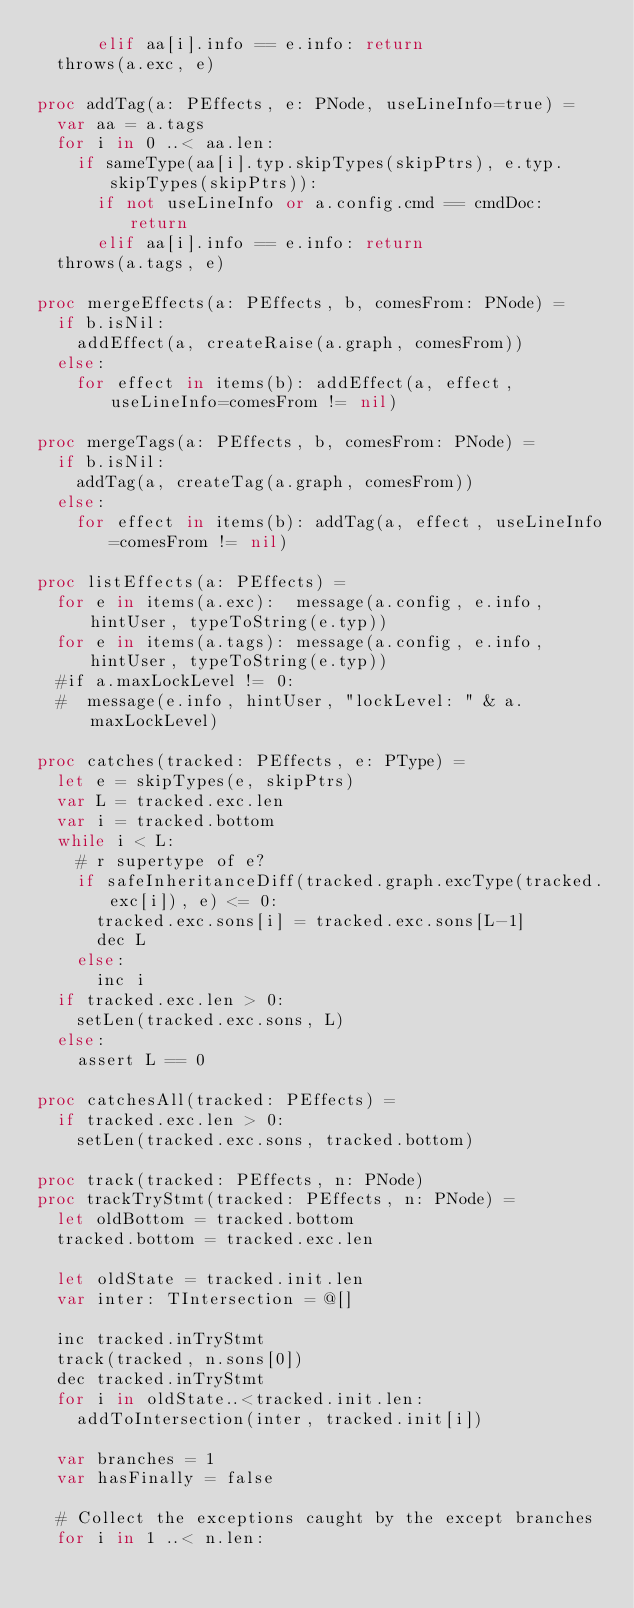<code> <loc_0><loc_0><loc_500><loc_500><_Nim_>      elif aa[i].info == e.info: return
  throws(a.exc, e)

proc addTag(a: PEffects, e: PNode, useLineInfo=true) =
  var aa = a.tags
  for i in 0 ..< aa.len:
    if sameType(aa[i].typ.skipTypes(skipPtrs), e.typ.skipTypes(skipPtrs)):
      if not useLineInfo or a.config.cmd == cmdDoc: return
      elif aa[i].info == e.info: return
  throws(a.tags, e)

proc mergeEffects(a: PEffects, b, comesFrom: PNode) =
  if b.isNil:
    addEffect(a, createRaise(a.graph, comesFrom))
  else:
    for effect in items(b): addEffect(a, effect, useLineInfo=comesFrom != nil)

proc mergeTags(a: PEffects, b, comesFrom: PNode) =
  if b.isNil:
    addTag(a, createTag(a.graph, comesFrom))
  else:
    for effect in items(b): addTag(a, effect, useLineInfo=comesFrom != nil)

proc listEffects(a: PEffects) =
  for e in items(a.exc):  message(a.config, e.info, hintUser, typeToString(e.typ))
  for e in items(a.tags): message(a.config, e.info, hintUser, typeToString(e.typ))
  #if a.maxLockLevel != 0:
  #  message(e.info, hintUser, "lockLevel: " & a.maxLockLevel)

proc catches(tracked: PEffects, e: PType) =
  let e = skipTypes(e, skipPtrs)
  var L = tracked.exc.len
  var i = tracked.bottom
  while i < L:
    # r supertype of e?
    if safeInheritanceDiff(tracked.graph.excType(tracked.exc[i]), e) <= 0:
      tracked.exc.sons[i] = tracked.exc.sons[L-1]
      dec L
    else:
      inc i
  if tracked.exc.len > 0:
    setLen(tracked.exc.sons, L)
  else:
    assert L == 0

proc catchesAll(tracked: PEffects) =
  if tracked.exc.len > 0:
    setLen(tracked.exc.sons, tracked.bottom)

proc track(tracked: PEffects, n: PNode)
proc trackTryStmt(tracked: PEffects, n: PNode) =
  let oldBottom = tracked.bottom
  tracked.bottom = tracked.exc.len

  let oldState = tracked.init.len
  var inter: TIntersection = @[]

  inc tracked.inTryStmt
  track(tracked, n.sons[0])
  dec tracked.inTryStmt
  for i in oldState..<tracked.init.len:
    addToIntersection(inter, tracked.init[i])

  var branches = 1
  var hasFinally = false

  # Collect the exceptions caught by the except branches
  for i in 1 ..< n.len:</code> 